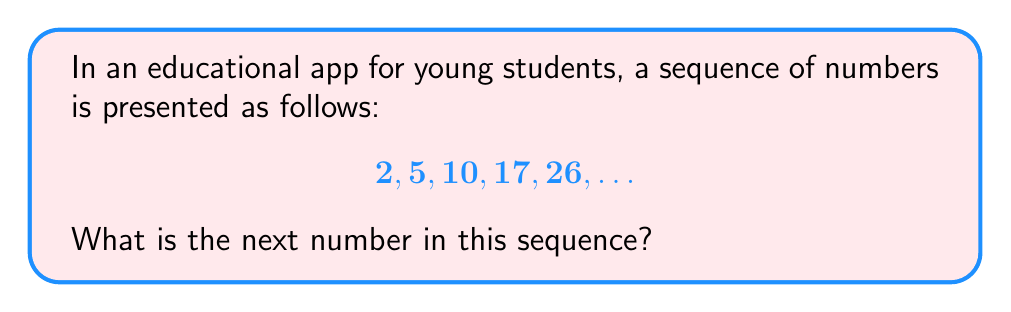Give your solution to this math problem. To find the next number in the sequence, we need to identify the pattern. Let's analyze the differences between consecutive terms:

1) From 2 to 5: $5 - 2 = 3$
2) From 5 to 10: $10 - 5 = 5$
3) From 10 to 17: $17 - 10 = 7$
4) From 17 to 26: $26 - 17 = 9$

We can see that the differences are increasing by 2 each time: 3, 5, 7, 9.

Following this pattern, the next difference should be 11.

To find the next number in the sequence:
$26 + 11 = 37$

Therefore, the next number in the sequence is 37.

This type of sequence, where the differences between consecutive terms form an arithmetic sequence, is called a quadratic sequence.
Answer: 37 